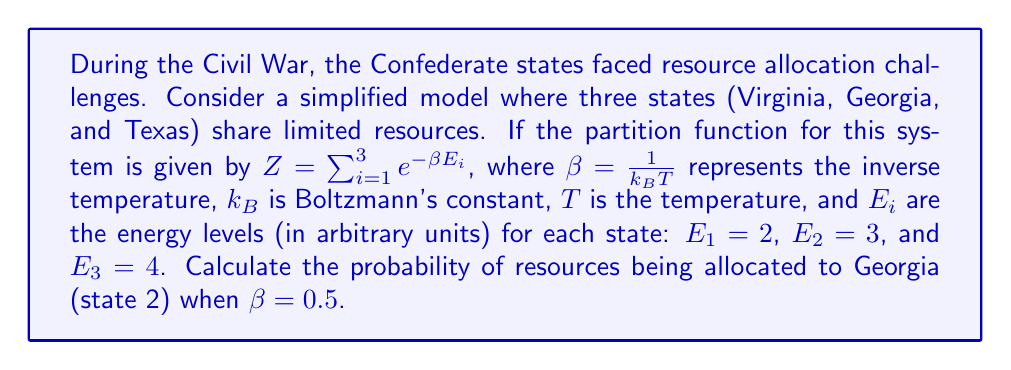Can you answer this question? To solve this problem, we'll follow these steps:

1) First, we need to calculate the partition function $Z$:
   $$Z = e^{-\beta E_1} + e^{-\beta E_2} + e^{-\beta E_3}$$

2) Substitute the given values:
   $$Z = e^{-0.5 \cdot 2} + e^{-0.5 \cdot 3} + e^{-0.5 \cdot 4}$$

3) Calculate each term:
   $$Z = e^{-1} + e^{-1.5} + e^{-2}$$
   $$Z \approx 0.3679 + 0.2231 + 0.1353 \approx 0.7263$$

4) The probability of resources being allocated to Georgia (state 2) is given by:
   $$P_2 = \frac{e^{-\beta E_2}}{Z}$$

5) Substitute the values:
   $$P_2 = \frac{e^{-0.5 \cdot 3}}{0.7263}$$

6) Calculate:
   $$P_2 = \frac{0.2231}{0.7263} \approx 0.3071$$

Therefore, the probability of resources being allocated to Georgia is approximately 0.3071 or 30.71%.
Answer: 0.3071 